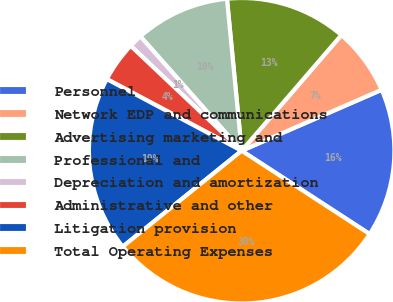Convert chart. <chart><loc_0><loc_0><loc_500><loc_500><pie_chart><fcel>Personnel<fcel>Network EDP and communications<fcel>Advertising marketing and<fcel>Professional and<fcel>Depreciation and amortization<fcel>Administrative and other<fcel>Litigation provision<fcel>Total Operating Expenses<nl><fcel>15.72%<fcel>7.14%<fcel>12.86%<fcel>10.0%<fcel>1.41%<fcel>4.28%<fcel>18.58%<fcel>30.02%<nl></chart> 